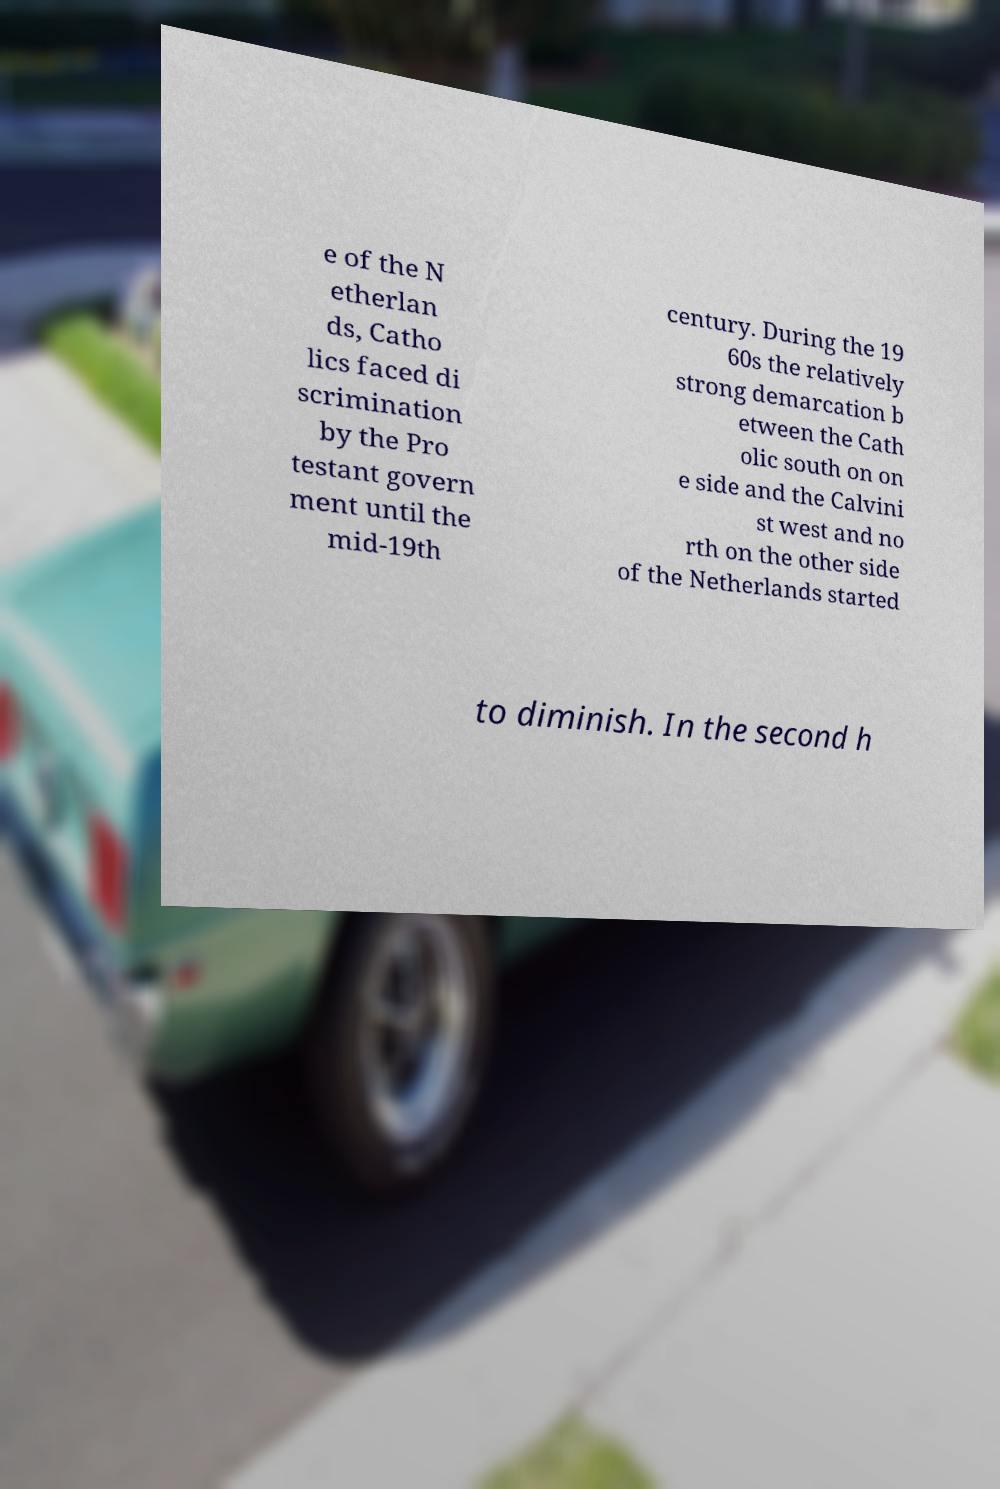Please identify and transcribe the text found in this image. e of the N etherlan ds, Catho lics faced di scrimination by the Pro testant govern ment until the mid-19th century. During the 19 60s the relatively strong demarcation b etween the Cath olic south on on e side and the Calvini st west and no rth on the other side of the Netherlands started to diminish. In the second h 